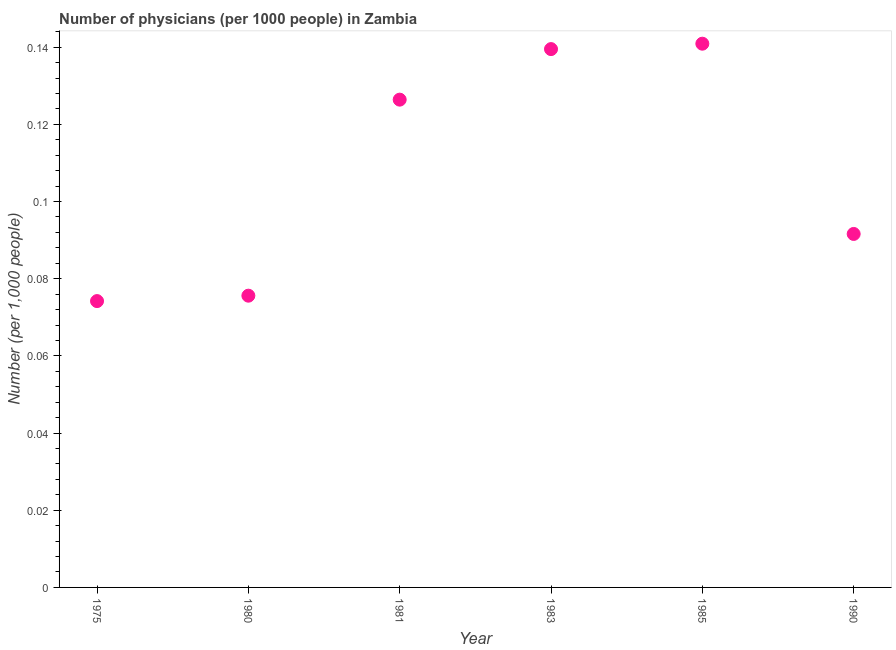What is the number of physicians in 1980?
Your answer should be very brief. 0.08. Across all years, what is the maximum number of physicians?
Your answer should be very brief. 0.14. Across all years, what is the minimum number of physicians?
Provide a succinct answer. 0.07. In which year was the number of physicians maximum?
Your answer should be compact. 1985. In which year was the number of physicians minimum?
Provide a succinct answer. 1975. What is the sum of the number of physicians?
Offer a terse response. 0.65. What is the difference between the number of physicians in 1983 and 1990?
Offer a terse response. 0.05. What is the average number of physicians per year?
Keep it short and to the point. 0.11. What is the median number of physicians?
Your response must be concise. 0.11. In how many years, is the number of physicians greater than 0.02 ?
Give a very brief answer. 6. What is the ratio of the number of physicians in 1975 to that in 1983?
Give a very brief answer. 0.53. Is the difference between the number of physicians in 1981 and 1983 greater than the difference between any two years?
Keep it short and to the point. No. What is the difference between the highest and the second highest number of physicians?
Offer a terse response. 0. What is the difference between the highest and the lowest number of physicians?
Give a very brief answer. 0.07. In how many years, is the number of physicians greater than the average number of physicians taken over all years?
Your answer should be very brief. 3. How many dotlines are there?
Your response must be concise. 1. What is the title of the graph?
Provide a succinct answer. Number of physicians (per 1000 people) in Zambia. What is the label or title of the X-axis?
Your response must be concise. Year. What is the label or title of the Y-axis?
Provide a short and direct response. Number (per 1,0 people). What is the Number (per 1,000 people) in 1975?
Your response must be concise. 0.07. What is the Number (per 1,000 people) in 1980?
Ensure brevity in your answer.  0.08. What is the Number (per 1,000 people) in 1981?
Provide a short and direct response. 0.13. What is the Number (per 1,000 people) in 1983?
Make the answer very short. 0.14. What is the Number (per 1,000 people) in 1985?
Offer a terse response. 0.14. What is the Number (per 1,000 people) in 1990?
Make the answer very short. 0.09. What is the difference between the Number (per 1,000 people) in 1975 and 1980?
Offer a very short reply. -0. What is the difference between the Number (per 1,000 people) in 1975 and 1981?
Your answer should be compact. -0.05. What is the difference between the Number (per 1,000 people) in 1975 and 1983?
Provide a succinct answer. -0.07. What is the difference between the Number (per 1,000 people) in 1975 and 1985?
Keep it short and to the point. -0.07. What is the difference between the Number (per 1,000 people) in 1975 and 1990?
Make the answer very short. -0.02. What is the difference between the Number (per 1,000 people) in 1980 and 1981?
Provide a short and direct response. -0.05. What is the difference between the Number (per 1,000 people) in 1980 and 1983?
Offer a terse response. -0.06. What is the difference between the Number (per 1,000 people) in 1980 and 1985?
Your answer should be very brief. -0.07. What is the difference between the Number (per 1,000 people) in 1980 and 1990?
Offer a very short reply. -0.02. What is the difference between the Number (per 1,000 people) in 1981 and 1983?
Ensure brevity in your answer.  -0.01. What is the difference between the Number (per 1,000 people) in 1981 and 1985?
Offer a very short reply. -0.01. What is the difference between the Number (per 1,000 people) in 1981 and 1990?
Make the answer very short. 0.03. What is the difference between the Number (per 1,000 people) in 1983 and 1985?
Offer a terse response. -0. What is the difference between the Number (per 1,000 people) in 1983 and 1990?
Ensure brevity in your answer.  0.05. What is the difference between the Number (per 1,000 people) in 1985 and 1990?
Your answer should be very brief. 0.05. What is the ratio of the Number (per 1,000 people) in 1975 to that in 1980?
Make the answer very short. 0.98. What is the ratio of the Number (per 1,000 people) in 1975 to that in 1981?
Your response must be concise. 0.59. What is the ratio of the Number (per 1,000 people) in 1975 to that in 1983?
Your answer should be very brief. 0.53. What is the ratio of the Number (per 1,000 people) in 1975 to that in 1985?
Your answer should be very brief. 0.53. What is the ratio of the Number (per 1,000 people) in 1975 to that in 1990?
Your answer should be very brief. 0.81. What is the ratio of the Number (per 1,000 people) in 1980 to that in 1981?
Provide a succinct answer. 0.6. What is the ratio of the Number (per 1,000 people) in 1980 to that in 1983?
Ensure brevity in your answer.  0.54. What is the ratio of the Number (per 1,000 people) in 1980 to that in 1985?
Provide a short and direct response. 0.54. What is the ratio of the Number (per 1,000 people) in 1980 to that in 1990?
Your answer should be very brief. 0.82. What is the ratio of the Number (per 1,000 people) in 1981 to that in 1983?
Your response must be concise. 0.91. What is the ratio of the Number (per 1,000 people) in 1981 to that in 1985?
Offer a very short reply. 0.9. What is the ratio of the Number (per 1,000 people) in 1981 to that in 1990?
Offer a very short reply. 1.38. What is the ratio of the Number (per 1,000 people) in 1983 to that in 1985?
Offer a terse response. 0.99. What is the ratio of the Number (per 1,000 people) in 1983 to that in 1990?
Your answer should be compact. 1.52. What is the ratio of the Number (per 1,000 people) in 1985 to that in 1990?
Provide a succinct answer. 1.54. 